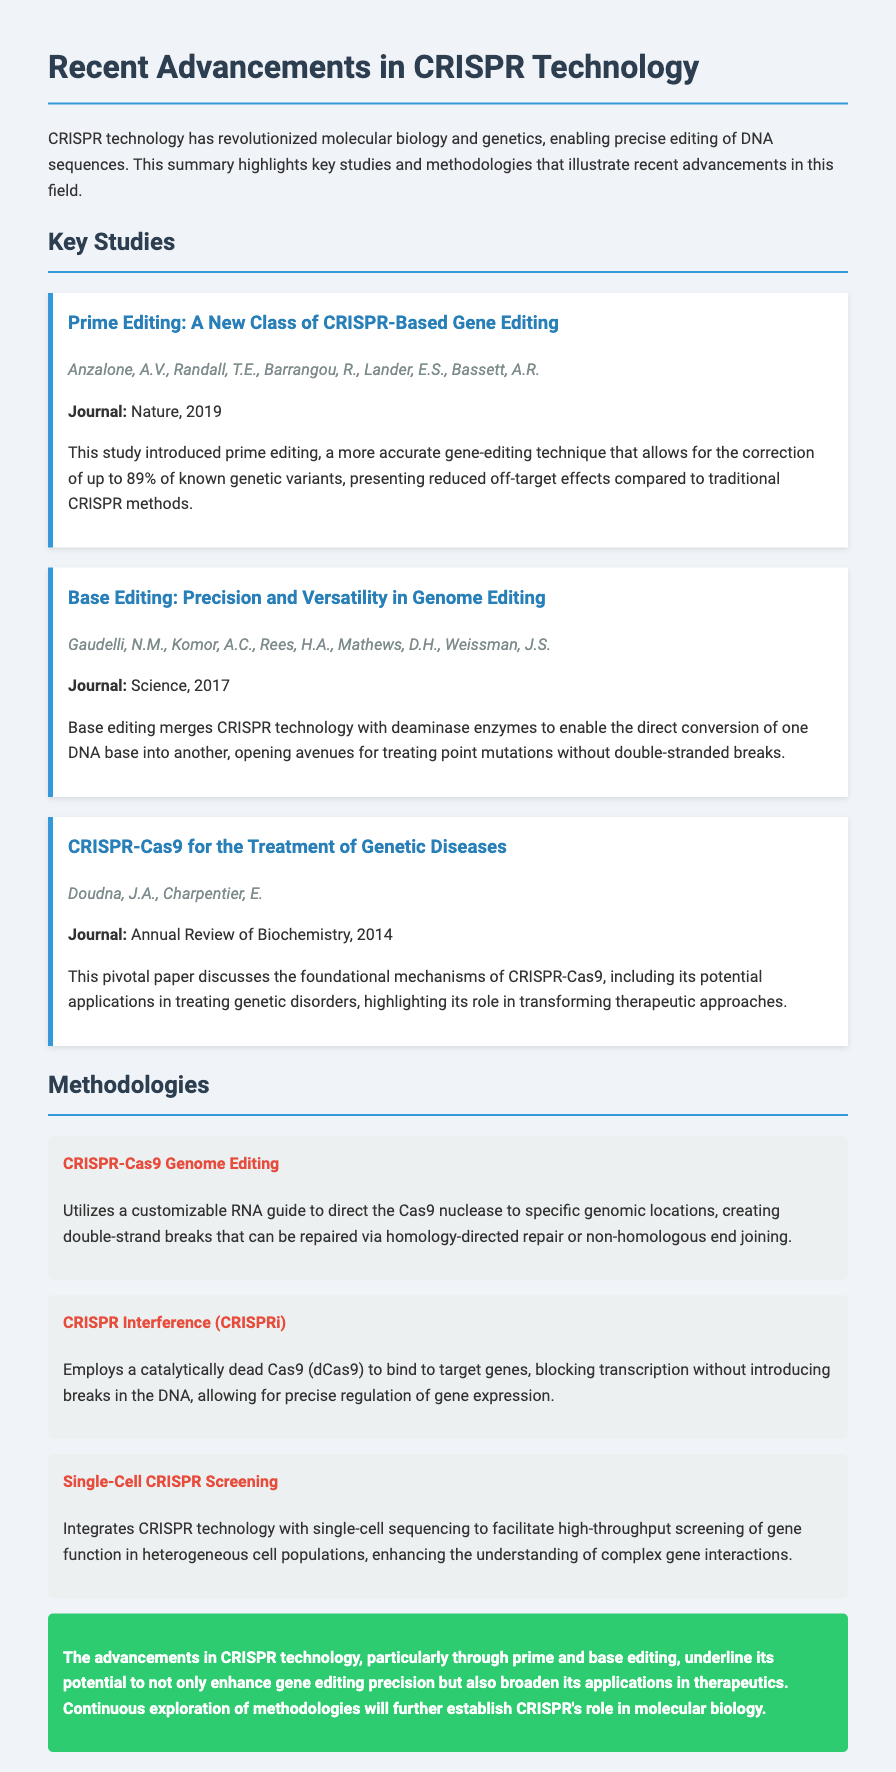What is the title of the first study? The title of the first study is "Prime Editing: A New Class of CRISPR-Based Gene Editing."
Answer: Prime Editing: A New Class of CRISPR-Based Gene Editing Who are the authors of the second study? The authors of the second study, titled "Base Editing: Precision and Versatility in Genome Editing," include Gaudelli, N.M., Komor, A.C., Rees, H.A., Mathews, D.H., and Weissman, J.S.
Answer: Gaudelli, N.M., Komor, A.C., Rees, H.A., Mathews, D.H., Weissman, J.S In what year was the "CRISPR-Cas9 for the Treatment of Genetic Diseases" study published? The study was published in the year 2014.
Answer: 2014 What technique does CRISPR Interference (CRISPRi) utilize? CRISPR Interference employs a catalytically dead Cas9 (dCas9) to block transcription.
Answer: Catalytically dead Cas9 (dCas9) How does prime editing improve traditional CRISPR methods? Prime editing allows for the correction of up to 89% of known genetic variants with reduced off-target effects.
Answer: Reduced off-target effects What is the main focus of the methodologies section in the document? The methodologies section outlines specific techniques used in CRISPR research and applications.
Answer: Specific techniques used in CRISPR research Which journal published the study on prime editing? The study on prime editing was published in the journal Nature.
Answer: Nature What is a key advantage of base editing mentioned in the document? A key advantage of base editing is the ability to treat point mutations without double-stranded breaks.
Answer: Treating point mutations without double-stranded breaks 